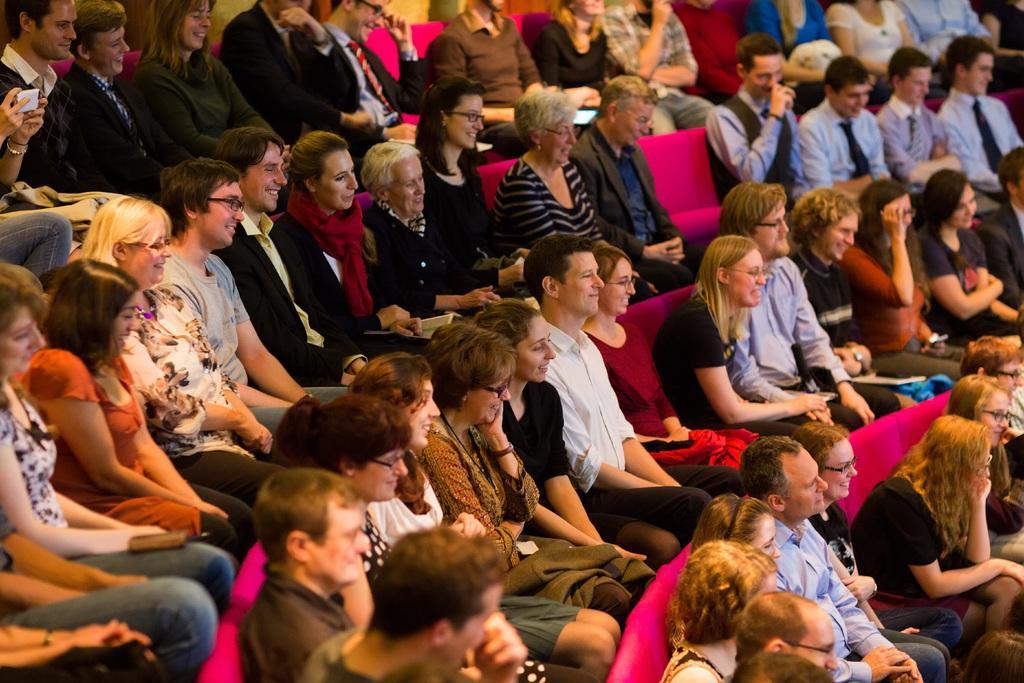Can you describe this image briefly? There are many people sitting on a pink color sofas. Some are wearing specs. 